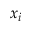Convert formula to latex. <formula><loc_0><loc_0><loc_500><loc_500>x _ { i }</formula> 